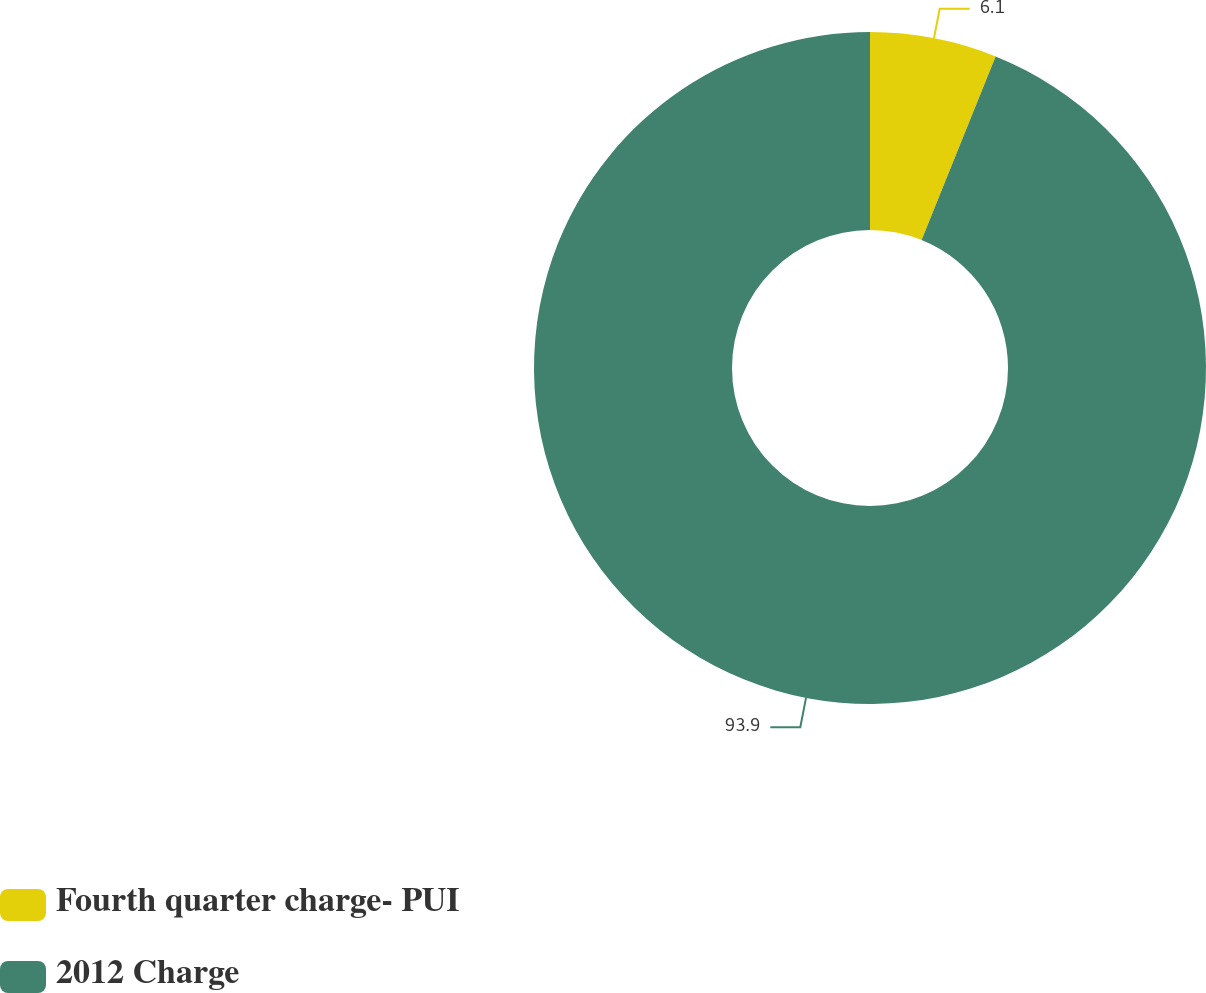<chart> <loc_0><loc_0><loc_500><loc_500><pie_chart><fcel>Fourth quarter charge- PUI<fcel>2012 Charge<nl><fcel>6.1%<fcel>93.9%<nl></chart> 